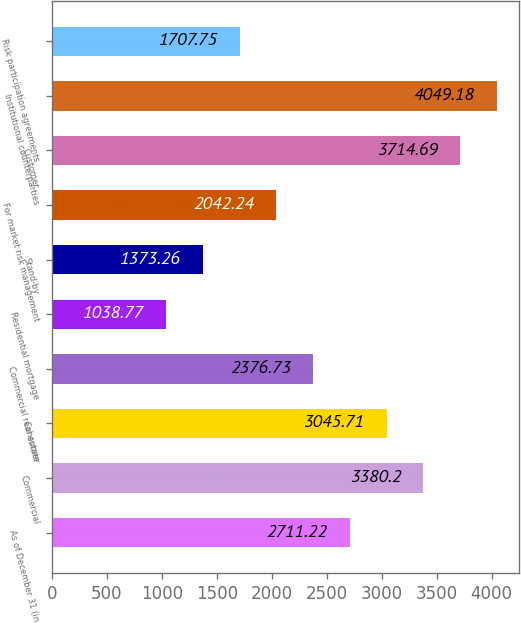Convert chart. <chart><loc_0><loc_0><loc_500><loc_500><bar_chart><fcel>As of December 31 (in<fcel>Commercial<fcel>Consumer<fcel>Commercial real estate<fcel>Residential mortgage<fcel>Stand-by<fcel>For market risk management<fcel>Customer<fcel>Institutional counterparties<fcel>Risk participation agreements<nl><fcel>2711.22<fcel>3380.2<fcel>3045.71<fcel>2376.73<fcel>1038.77<fcel>1373.26<fcel>2042.24<fcel>3714.69<fcel>4049.18<fcel>1707.75<nl></chart> 